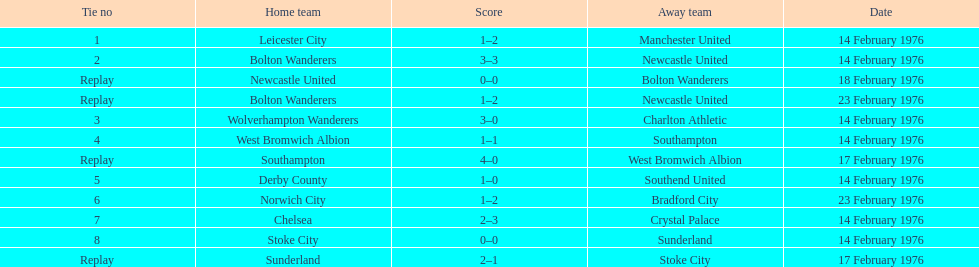Who was the home team in the game on the top of the table? Leicester City. 